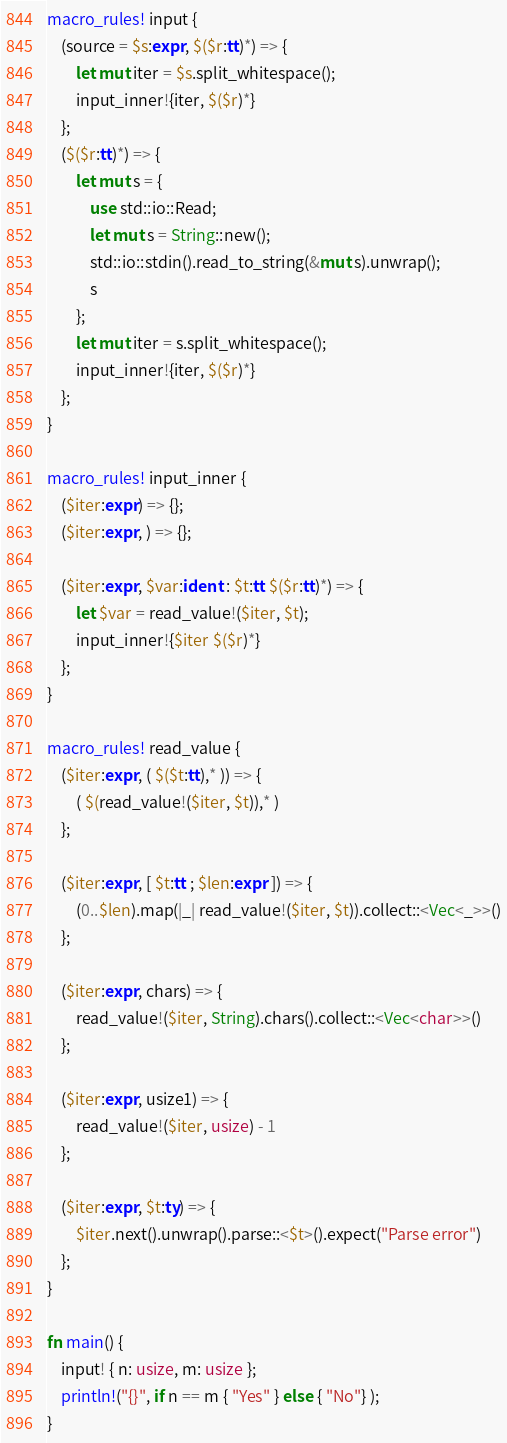Convert code to text. <code><loc_0><loc_0><loc_500><loc_500><_Rust_>macro_rules! input {
    (source = $s:expr, $($r:tt)*) => {
        let mut iter = $s.split_whitespace();
        input_inner!{iter, $($r)*}
    };
    ($($r:tt)*) => {
        let mut s = {
            use std::io::Read;
            let mut s = String::new();
            std::io::stdin().read_to_string(&mut s).unwrap();
            s
        };
        let mut iter = s.split_whitespace();
        input_inner!{iter, $($r)*}
    };
}

macro_rules! input_inner {
    ($iter:expr) => {};
    ($iter:expr, ) => {};

    ($iter:expr, $var:ident : $t:tt $($r:tt)*) => {
        let $var = read_value!($iter, $t);
        input_inner!{$iter $($r)*}
    };
}

macro_rules! read_value {
    ($iter:expr, ( $($t:tt),* )) => {
        ( $(read_value!($iter, $t)),* )
    };

    ($iter:expr, [ $t:tt ; $len:expr ]) => {
        (0..$len).map(|_| read_value!($iter, $t)).collect::<Vec<_>>()
    };

    ($iter:expr, chars) => {
        read_value!($iter, String).chars().collect::<Vec<char>>()
    };

    ($iter:expr, usize1) => {
        read_value!($iter, usize) - 1
    };

    ($iter:expr, $t:ty) => {
        $iter.next().unwrap().parse::<$t>().expect("Parse error")
    };
}

fn main() {
    input! { n: usize, m: usize };
    println!("{}", if n == m { "Yes" } else { "No"} );
}
</code> 